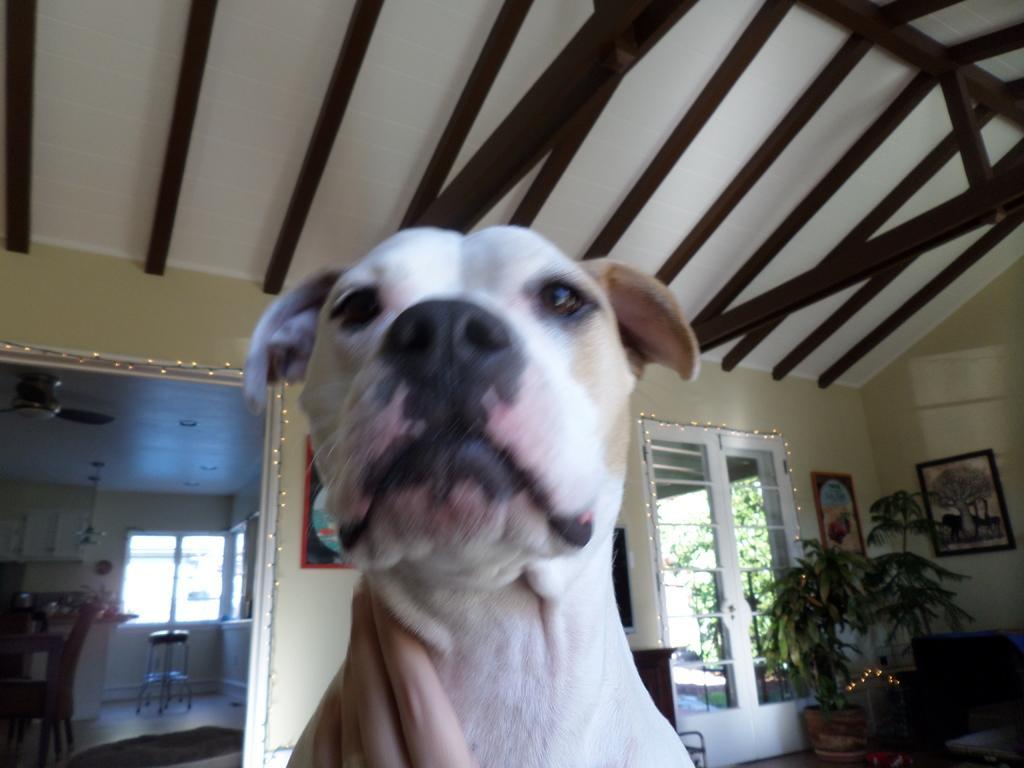Describe this image in one or two sentences. There is a white color dog at the bottom of this image and there is a wall in the background. There is a window on the left side of this image and right side of this image as well. There are some trees on the right side of this image. There are two photo frames are attached to the wall, and there is a table and some chairs are present at present on the left side of this image. 